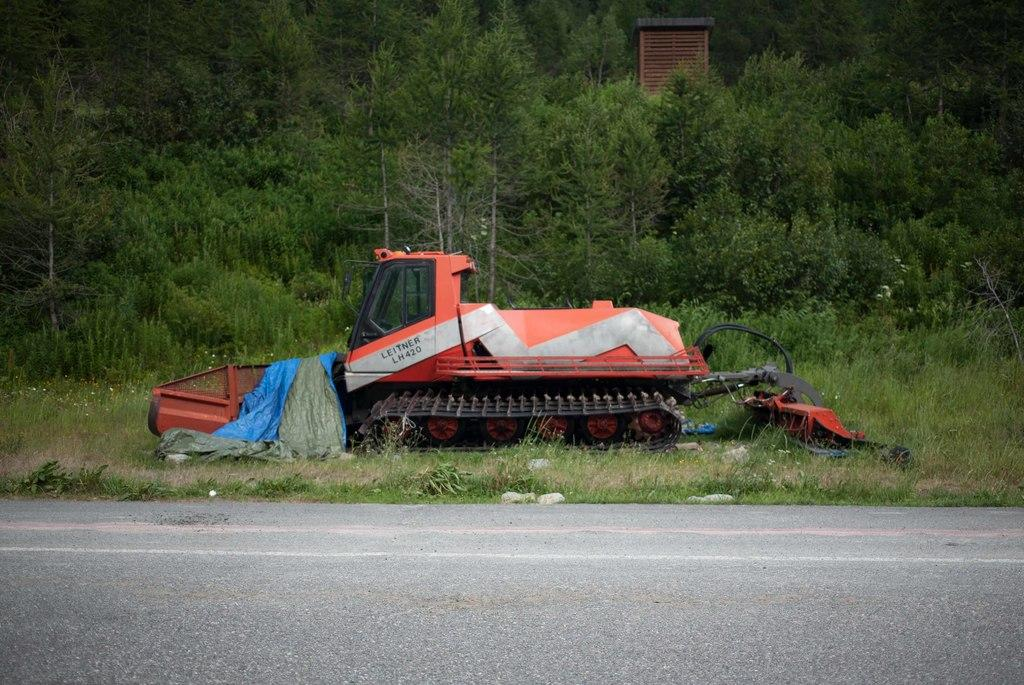Where was the image taken? The image was clicked outside. What is the main subject in the center of the image? There is a vehicle in the center of the image, which appears to be a crane. What type of terrain can be seen in the image? There is grass visible in the image, and a concrete road is present. What other natural elements are present in the image? There are plants and trees visible in the image. Are there any other objects or structures in the image? Yes, there are other objects in the image. What is the number of cents visible in the image? There are no cents present in the image. What type of lipstick can be seen on the crane in the image? There is no lipstick or any cosmetic product visible in the image. 